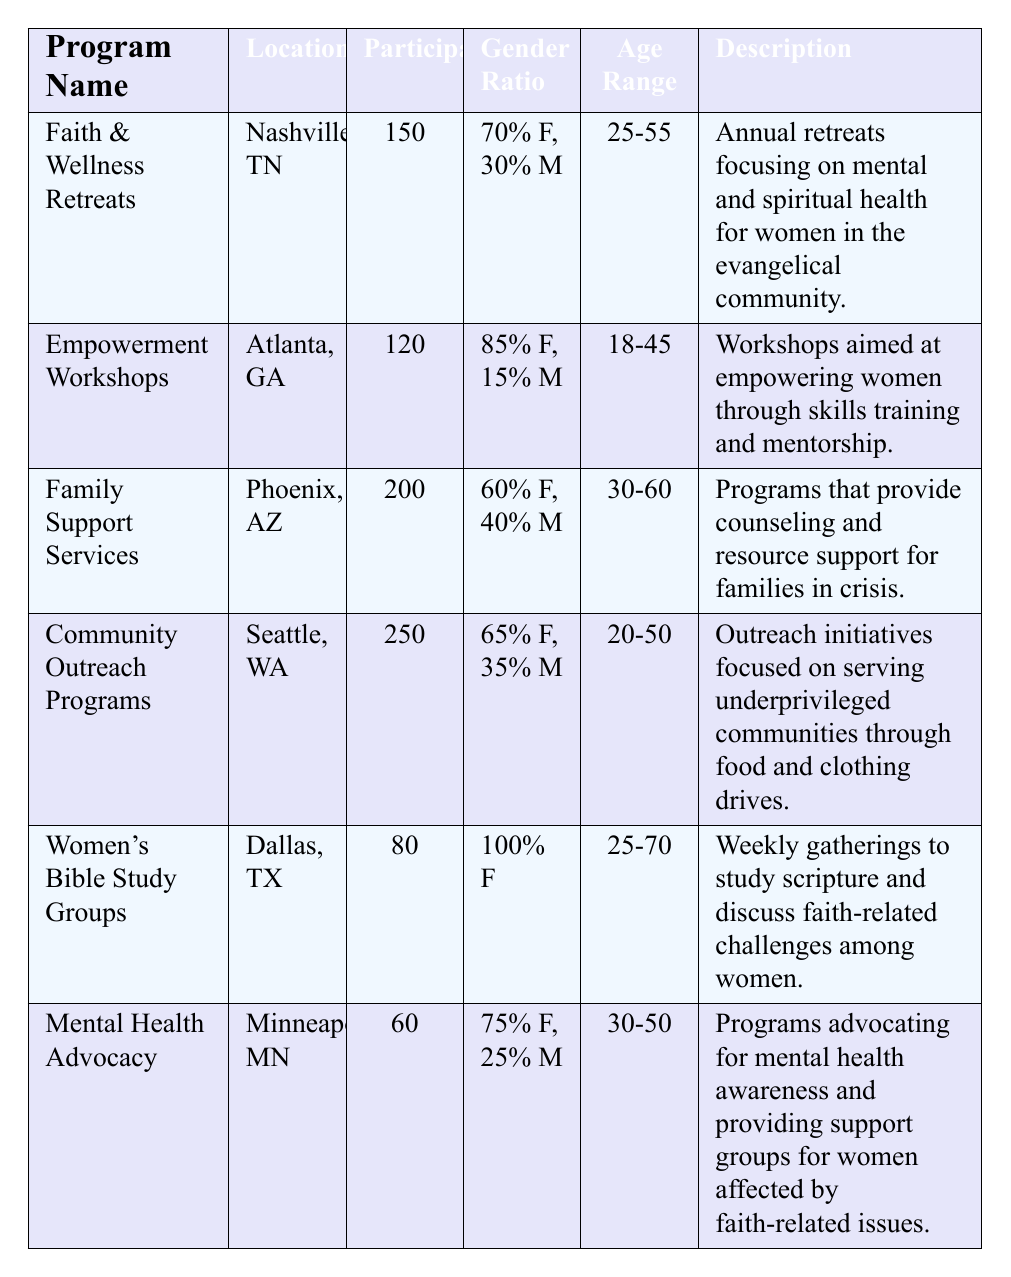What is the total number of participants across all programs? To find the total number of participants, add the number of participants in each program: 150 + 120 + 200 + 250 + 80 + 60 = 860.
Answer: 860 Which program has the highest number of participants? The program with the highest number of participants is "Community Outreach Programs" with 250 participants.
Answer: Community Outreach Programs What percentage of participants are female in the "Women's Bible Study Groups"? The "Women's Bible Study Groups" has 100% of participants as female.
Answer: 100% What is the age range for the "Empowerment Workshops"? The age range for the "Empowerment Workshops" is 18-45 years.
Answer: 18-45 How many more participants are in "Family Support Services" compared to "Mental Health Advocacy"? The difference in participants is calculated as 200 (Family Support Services) - 60 (Mental Health Advocacy) = 140.
Answer: 140 Which location has an empowerment-focused program? The "Empowerment Workshops" located in Atlanta, GA, focuses on empowering women.
Answer: Atlanta, GA Is there any program where the gender ratio is exclusively female? Yes, the "Women's Bible Study Groups" has a gender ratio of 100% female.
Answer: Yes What is the average number of participants across all programs? To find the average, add the participants (150 + 120 + 200 + 250 + 80 + 60 = 860) and divide by the number of programs (6). 860/6 = 143.33.
Answer: 143.33 Which two programs have a similar participant range? "Faith & Wellness Retreats" (150) and "Empowerment Workshops" (120) are the closest with 30 participants apart.
Answer: Faith & Wellness Retreats and Empowerment Workshops Does any program focus specifically on mental health advocacy? Yes, "Mental Health Advocacy" specifically focuses on mental health awareness and support.
Answer: Yes 